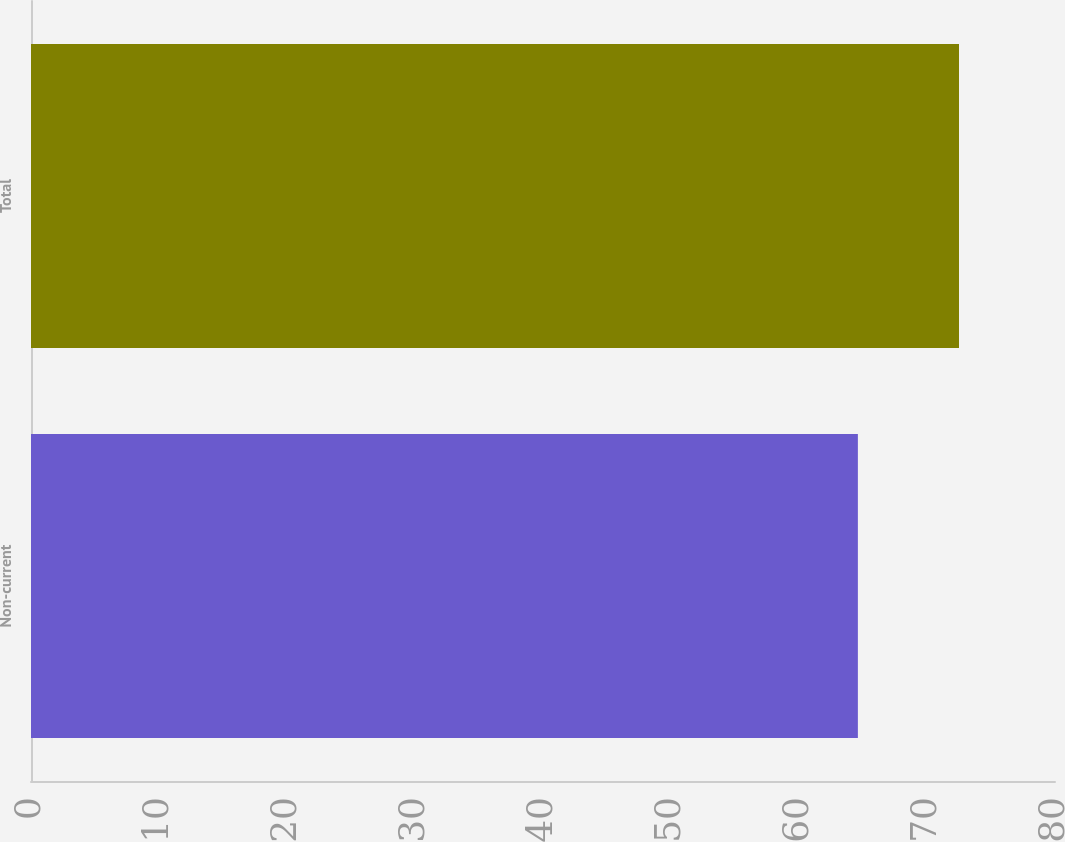<chart> <loc_0><loc_0><loc_500><loc_500><bar_chart><fcel>Non-current<fcel>Total<nl><fcel>64.6<fcel>72.5<nl></chart> 